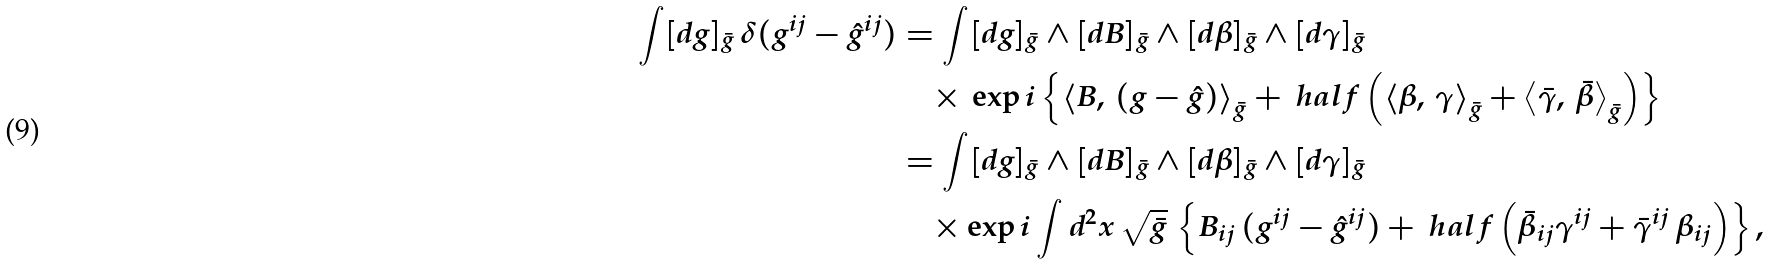<formula> <loc_0><loc_0><loc_500><loc_500>\int [ d g ] _ { \bar { g } } \, \delta ( g ^ { i j } - \hat { g } ^ { i j } ) & = \int [ d g ] _ { \bar { g } } \wedge [ d B ] _ { \bar { g } } \wedge [ d \beta ] _ { \bar { g } } \wedge [ d \gamma ] _ { \bar { g } } \\ & \quad \times \, \exp i \left \{ \left \langle B , \, ( g - \hat { g } ) \right \rangle _ { \bar { g } } + \ h a l f \left ( \left \langle \beta , \, \gamma \right \rangle _ { \bar { g } } + \left \langle \bar { \gamma } , \, \bar { \beta } \right \rangle _ { \bar { g } } \right ) \right \} \\ & = \int [ d g ] _ { \bar { g } } \wedge [ d B ] _ { \bar { g } } \wedge [ d \beta ] _ { \bar { g } } \wedge [ d \gamma ] _ { \bar { g } } \\ & \quad \times \exp i \int d ^ { 2 } x \, \sqrt { \bar { g } } \, \left \{ B _ { i j } \, ( g ^ { i j } - \hat { g } ^ { i j } ) + \ h a l f \left ( \bar { \beta } _ { i j } \gamma ^ { i j } + \bar { \gamma } ^ { i j } \, \beta _ { i j } \right ) \right \} ,</formula> 